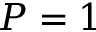<formula> <loc_0><loc_0><loc_500><loc_500>P = 1</formula> 